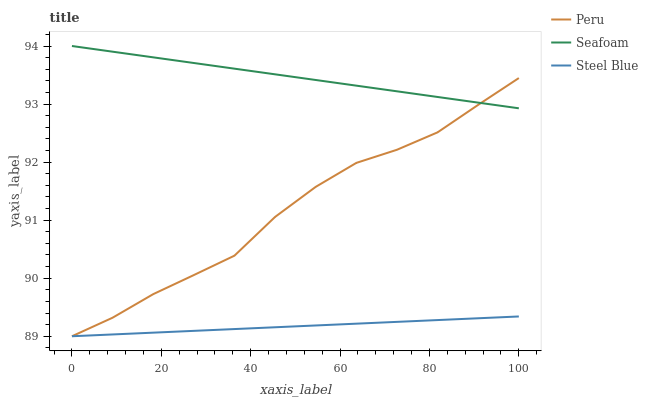Does Steel Blue have the minimum area under the curve?
Answer yes or no. Yes. Does Seafoam have the maximum area under the curve?
Answer yes or no. Yes. Does Peru have the minimum area under the curve?
Answer yes or no. No. Does Peru have the maximum area under the curve?
Answer yes or no. No. Is Steel Blue the smoothest?
Answer yes or no. Yes. Is Peru the roughest?
Answer yes or no. Yes. Is Peru the smoothest?
Answer yes or no. No. Is Steel Blue the roughest?
Answer yes or no. No. Does Peru have the lowest value?
Answer yes or no. Yes. Does Seafoam have the highest value?
Answer yes or no. Yes. Does Peru have the highest value?
Answer yes or no. No. Is Steel Blue less than Seafoam?
Answer yes or no. Yes. Is Seafoam greater than Steel Blue?
Answer yes or no. Yes. Does Peru intersect Seafoam?
Answer yes or no. Yes. Is Peru less than Seafoam?
Answer yes or no. No. Is Peru greater than Seafoam?
Answer yes or no. No. Does Steel Blue intersect Seafoam?
Answer yes or no. No. 